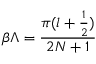<formula> <loc_0><loc_0><loc_500><loc_500>\beta \Lambda = \frac { \pi ( l + \frac { 1 } { 2 } ) } { 2 N + 1 }</formula> 